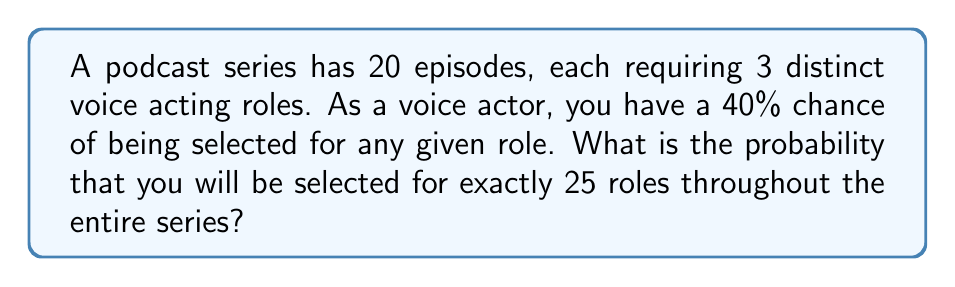Provide a solution to this math problem. Let's approach this step-by-step:

1) First, we need to calculate the total number of role opportunities:
   $20 \text{ episodes} \times 3 \text{ roles per episode} = 60 \text{ total roles}$

2) This scenario follows a binomial distribution, where:
   $n = 60$ (total number of trials)
   $p = 0.40$ (probability of success on each trial)
   $k = 25$ (number of successes we're interested in)

3) The probability mass function for a binomial distribution is:

   $$P(X = k) = \binom{n}{k} p^k (1-p)^{n-k}$$

4) Substituting our values:

   $$P(X = 25) = \binom{60}{25} (0.40)^{25} (1-0.40)^{60-25}$$

5) Simplify:

   $$P(X = 25) = \binom{60}{25} (0.40)^{25} (0.60)^{35}$$

6) Calculate the binomial coefficient:

   $$\binom{60}{25} = \frac{60!}{25!(60-25)!} = \frac{60!}{25!35!} \approx 7.7066 \times 10^{16}$$

7) Now, let's calculate the full probability:

   $$P(X = 25) \approx (7.7066 \times 10^{16}) \times (0.40)^{25} \times (0.60)^{35}$$

8) Using a calculator or computer for precision:

   $$P(X = 25) \approx 0.0872 \text{ or } 8.72\%$$
Answer: 0.0872 